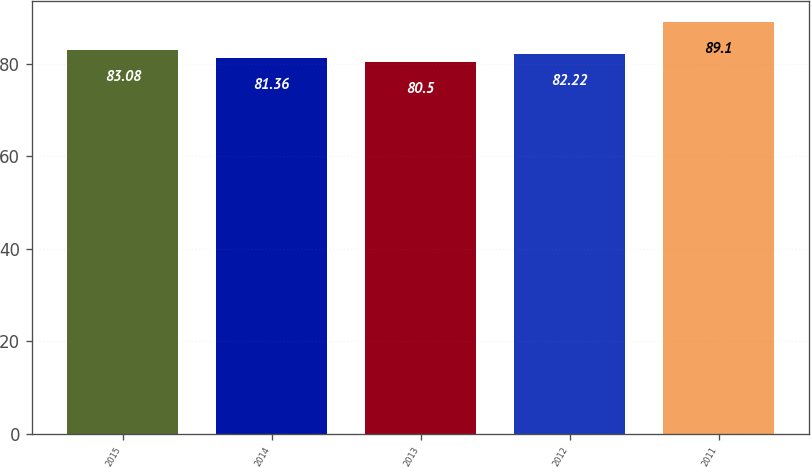Convert chart to OTSL. <chart><loc_0><loc_0><loc_500><loc_500><bar_chart><fcel>2015<fcel>2014<fcel>2013<fcel>2012<fcel>2011<nl><fcel>83.08<fcel>81.36<fcel>80.5<fcel>82.22<fcel>89.1<nl></chart> 